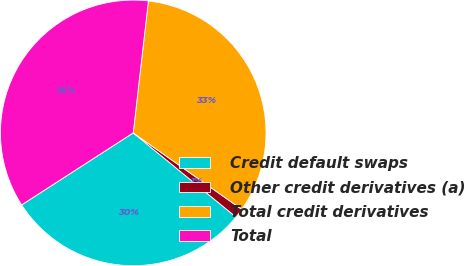Convert chart. <chart><loc_0><loc_0><loc_500><loc_500><pie_chart><fcel>Credit default swaps<fcel>Other credit derivatives (a)<fcel>Total credit derivatives<fcel>Total<nl><fcel>29.96%<fcel>1.15%<fcel>32.95%<fcel>35.95%<nl></chart> 